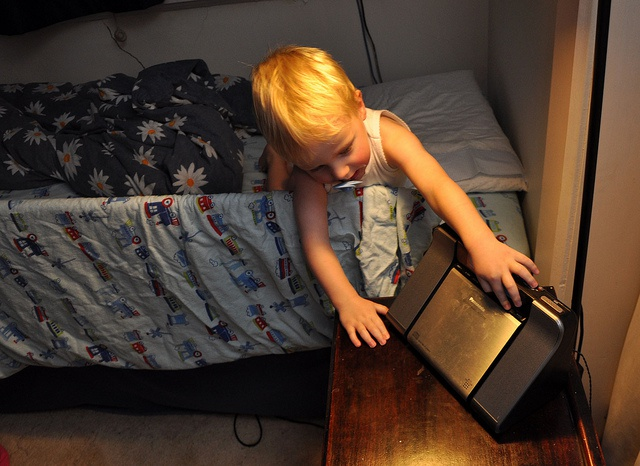Describe the objects in this image and their specific colors. I can see bed in black and gray tones and people in black, orange, maroon, and brown tones in this image. 